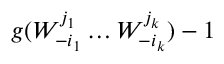Convert formula to latex. <formula><loc_0><loc_0><loc_500><loc_500>g ( W _ { - i _ { 1 } } ^ { j _ { 1 } } \dots W _ { - i _ { k } } ^ { j _ { k } } ) - 1</formula> 